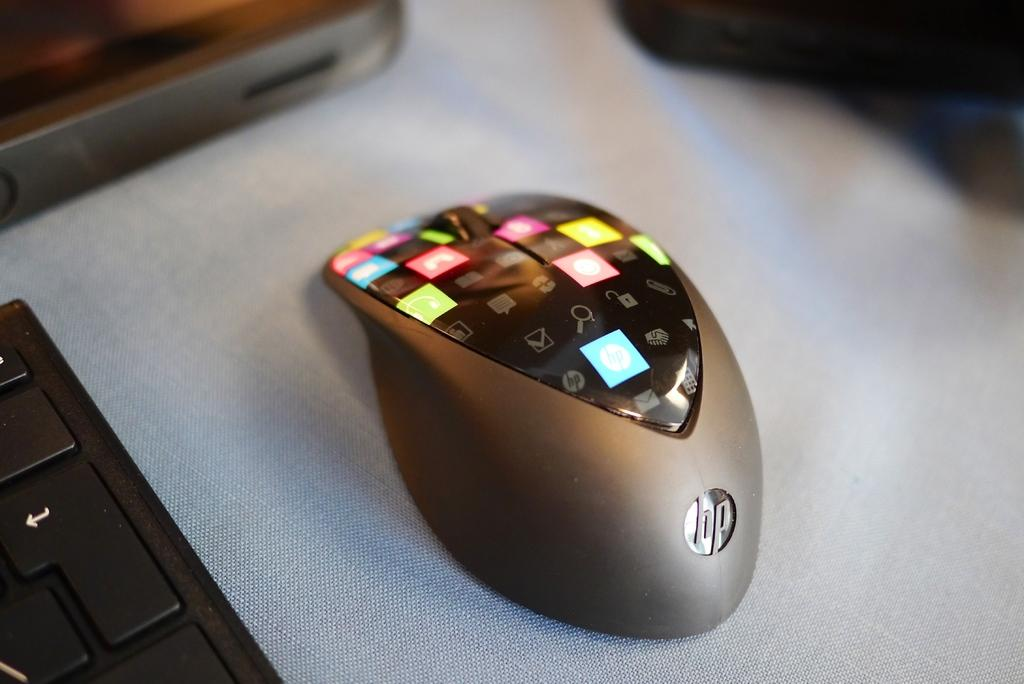<image>
Relay a brief, clear account of the picture shown. hp mouse with a digital display on top that is broken down into small squares, each one with a different picture of function 